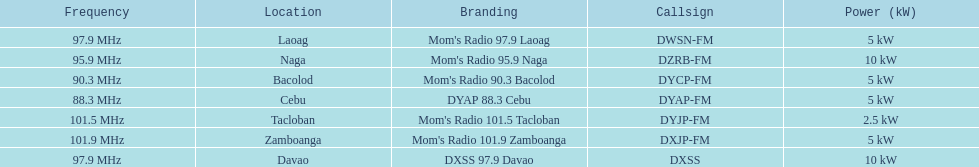What is the radio with the least about of mhz? DYAP 88.3 Cebu. 